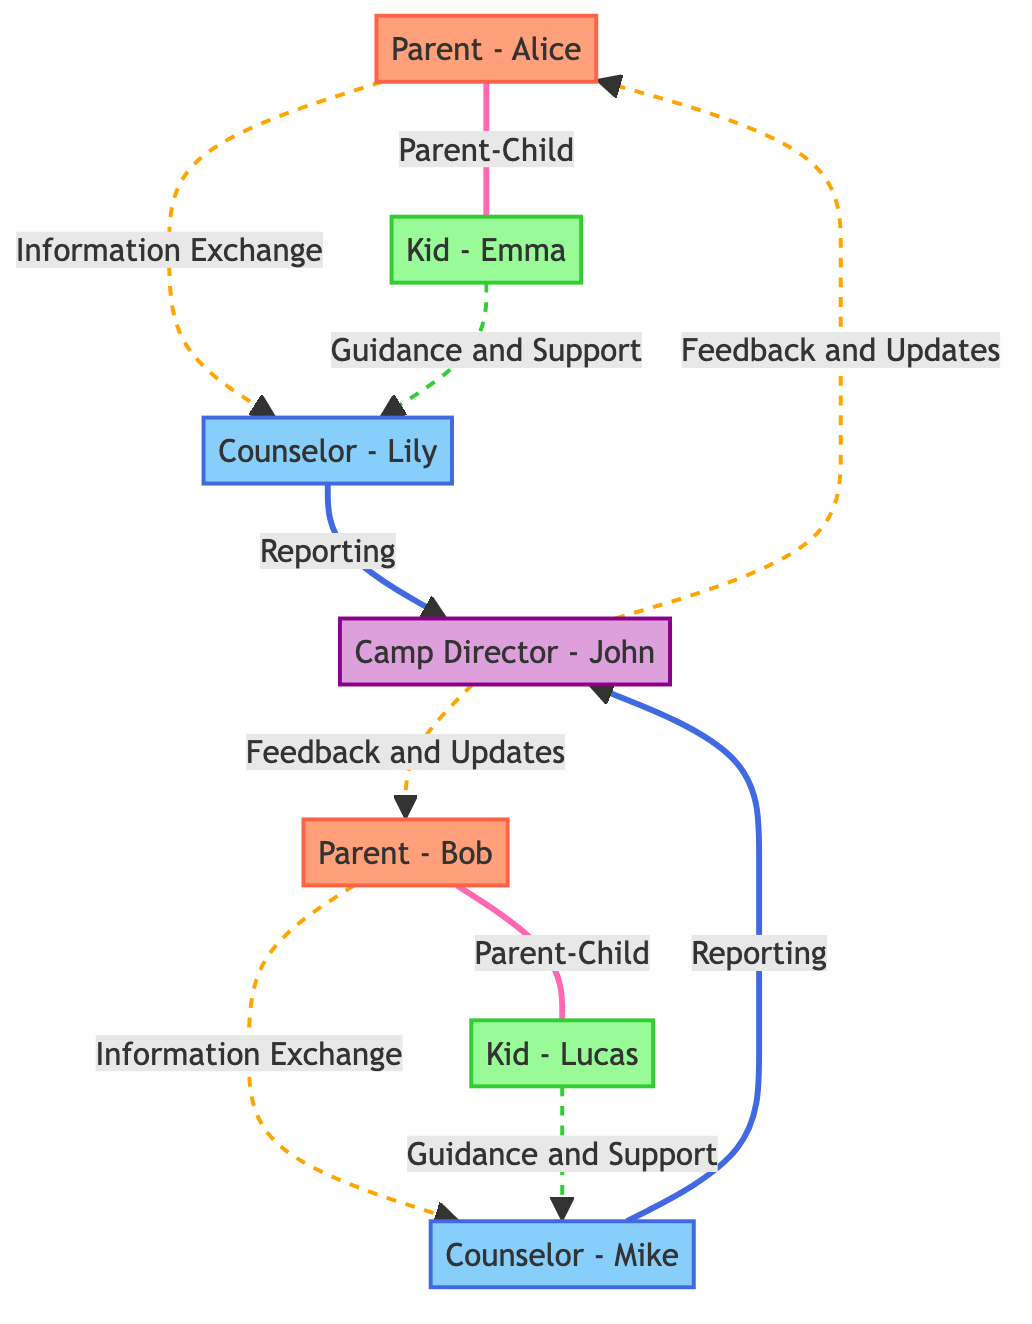What is the total number of nodes in the network diagram? The diagram lists six unique entities: Parent - Alice, Parent - Bob, Kid - Emma, Kid - Lucas, Counselor - Lily, Counselor - Mike, and Camp Director - John. Thus, the total number of nodes is calculated as 6.
Answer: 6 What type of relationship exists between Parent - Alice and Kid - Emma? The connection between Parent - Alice and Kid - Emma is labeled as "Parent-Child." This indicates the hierarchical family relationship that identifies Alice as Emma's parent.
Answer: Parent-Child Who is the Camp Director in the network? The diagram specifies one individual as the Camp Director: John. The label "Camp Director - John" indicates his role within the network and distinguishes him from others.
Answer: John How many information exchange relationships are present in the diagram? There are two edges that denote "Information Exchange": one from Parent - Alice to Counselor - Lily and the other from Parent - Bob to Counselor - Mike. Counting these edges gives a total of 2 information exchange relationships.
Answer: 2 Which counselor is connected to Kid - Emma? According to the diagram, Kid - Emma is linked to Counselor - Lily through the "Guidance and Support" relationship. This relationship shows that the counselor is providing assistance to that specific child.
Answer: Counselor - Lily What are the types of relationships between the counselors and the Camp Director? The counselors, Counselor - Lily and Counselor - Mike, both have a "Reporting" relationship with the Camp Director - John. This indicates that both counselors report their activities or issues to the director.
Answer: Reporting What type of communication occurs between the Camp Director and Parent - Bob? The communication between Camp Director - John and Parent - Bob is categorized as "Feedback and Updates." This signifies that the director provides information or responses back to the parent regarding camp matters.
Answer: Feedback and Updates How many kids are directly linked to parents in this diagram? There are two direct connections where each parent is linked to one kid: Parent - Alice with Kid - Emma and Parent - Bob with Kid - Lucas. Therefore, the total number of kids directly linked to parents is 2.
Answer: 2 Which node has the most connections in the diagram? The Camp Director - John has four connections: two from the counselors for reporting, and two from the parents for feedback and updates. This makes him the node with the most connections (4).
Answer: Camp Director - John 